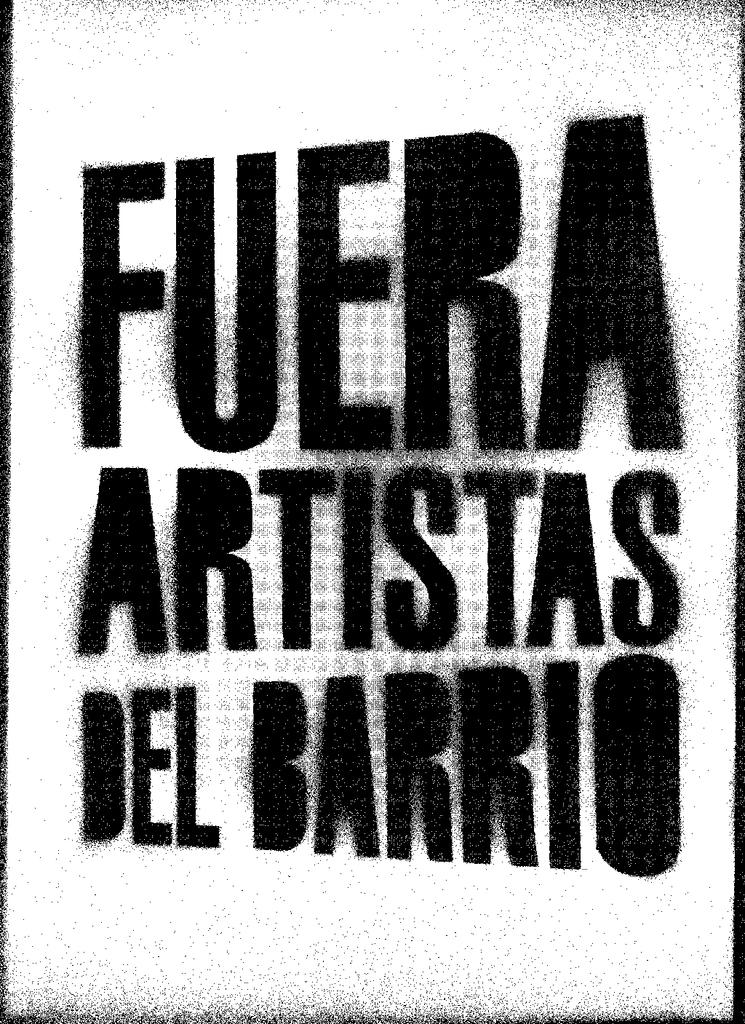What is some of the foreign text on this picture?
Make the answer very short. Fuera artistas del barrio. 